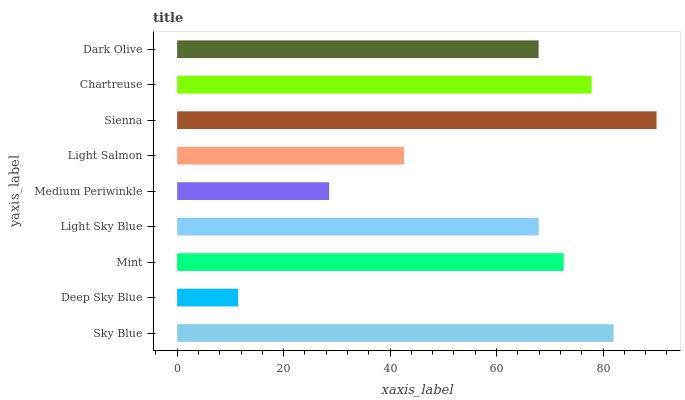Is Deep Sky Blue the minimum?
Answer yes or no. Yes. Is Sienna the maximum?
Answer yes or no. Yes. Is Mint the minimum?
Answer yes or no. No. Is Mint the maximum?
Answer yes or no. No. Is Mint greater than Deep Sky Blue?
Answer yes or no. Yes. Is Deep Sky Blue less than Mint?
Answer yes or no. Yes. Is Deep Sky Blue greater than Mint?
Answer yes or no. No. Is Mint less than Deep Sky Blue?
Answer yes or no. No. Is Light Sky Blue the high median?
Answer yes or no. Yes. Is Light Sky Blue the low median?
Answer yes or no. Yes. Is Medium Periwinkle the high median?
Answer yes or no. No. Is Deep Sky Blue the low median?
Answer yes or no. No. 